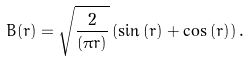Convert formula to latex. <formula><loc_0><loc_0><loc_500><loc_500>B ( r ) = \sqrt { \frac { 2 } { ( \pi r ) } } \left ( \sin { ( r ) } + \cos { ( r ) } \right ) .</formula> 